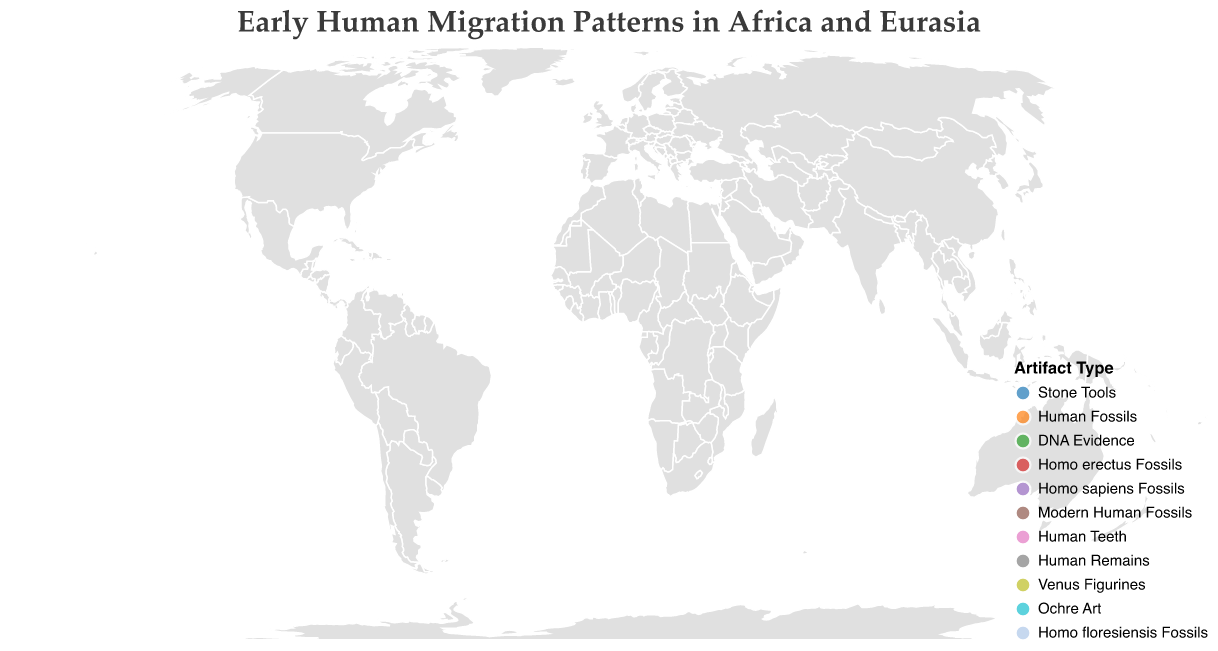How many sites are depicted on the map title "Early Human Migration Patterns in Africa and Eurasia"? Count the number of unique points on the map. There are 12 distinct sites plotted.
Answer: 12 Which site has the oldest artifact, and what type of artifact is it? Identify the site with the largest value for "Age (Years BP)". Jebel Irhoud in Morocco has the oldest artifact, which is Stone Tools.
Answer: Jebel Irhoud Morocco, Stone Tools Which two sites have the same time period (120,000 Years BP) and what types of artifacts are found there? Look for sites where "Age (Years BP)" is 120,000. Both Skhul Cave in Israel and Fuyan Cave in China have artifacts from 120,000 Years BP. Skhul Cave has Homo sapiens Fossils, and Fuyan Cave has Human Teeth.
Answer: Skhul Cave Israel (Homo sapiens Fossils) and Fuyan Cave China (Human Teeth) Compare the location and artifact type of the site in Georgia with that in South Africa. Identify the coordinates and artifact types for both sites. Dmanisi in Georgia (41.3377, 44.3378) has Homo erectus Fossils, whereas Blombos Cave in South Africa (-34.4167, 21.2167) has Ochre Art.
Answer: Dmanisi Georgia (Homo erectus Fossils) and Blombos Cave South Africa (Ochre Art) What is the age difference between the artifacts found in Denisova Cave, Russia, and Kostenki, Russia? Subtract the "Age (Years BP)" of Kostenki from that of Denisova Cave. Denisova Cave artifacts are 195,000 Years BP and Kostenki artifacts are 45,000 Years BP. The age difference is 195,000 - 45,000 = 150,000 years.
Answer: 150,000 years Identify the artifact type found in the site with the coordinates (51.2861, -2.7486). Check the site with the given coordinates. The artifact type found at Cheddar Gorge in England (51.2861, -2.7486) is Human Remains.
Answer: Human Remains Which artifact types are represented by more than one site on the map? Count the occurrences of each artifact type. Human Fossils (Misliya Cave and Skhul Cave) and Stone Tools (Jebel Irhoud and Madjedbebe) are each found at more than one site.
Answer: Human Fossils and Stone Tools How many sites are there in Africa? Identify sites with coordinates within the African continent. The sites in Africa are Jebel Irhoud Morocco, Blombos Cave South Africa, and Madjedbebe Australia. There are 3 sites in Africa.
Answer: 3 